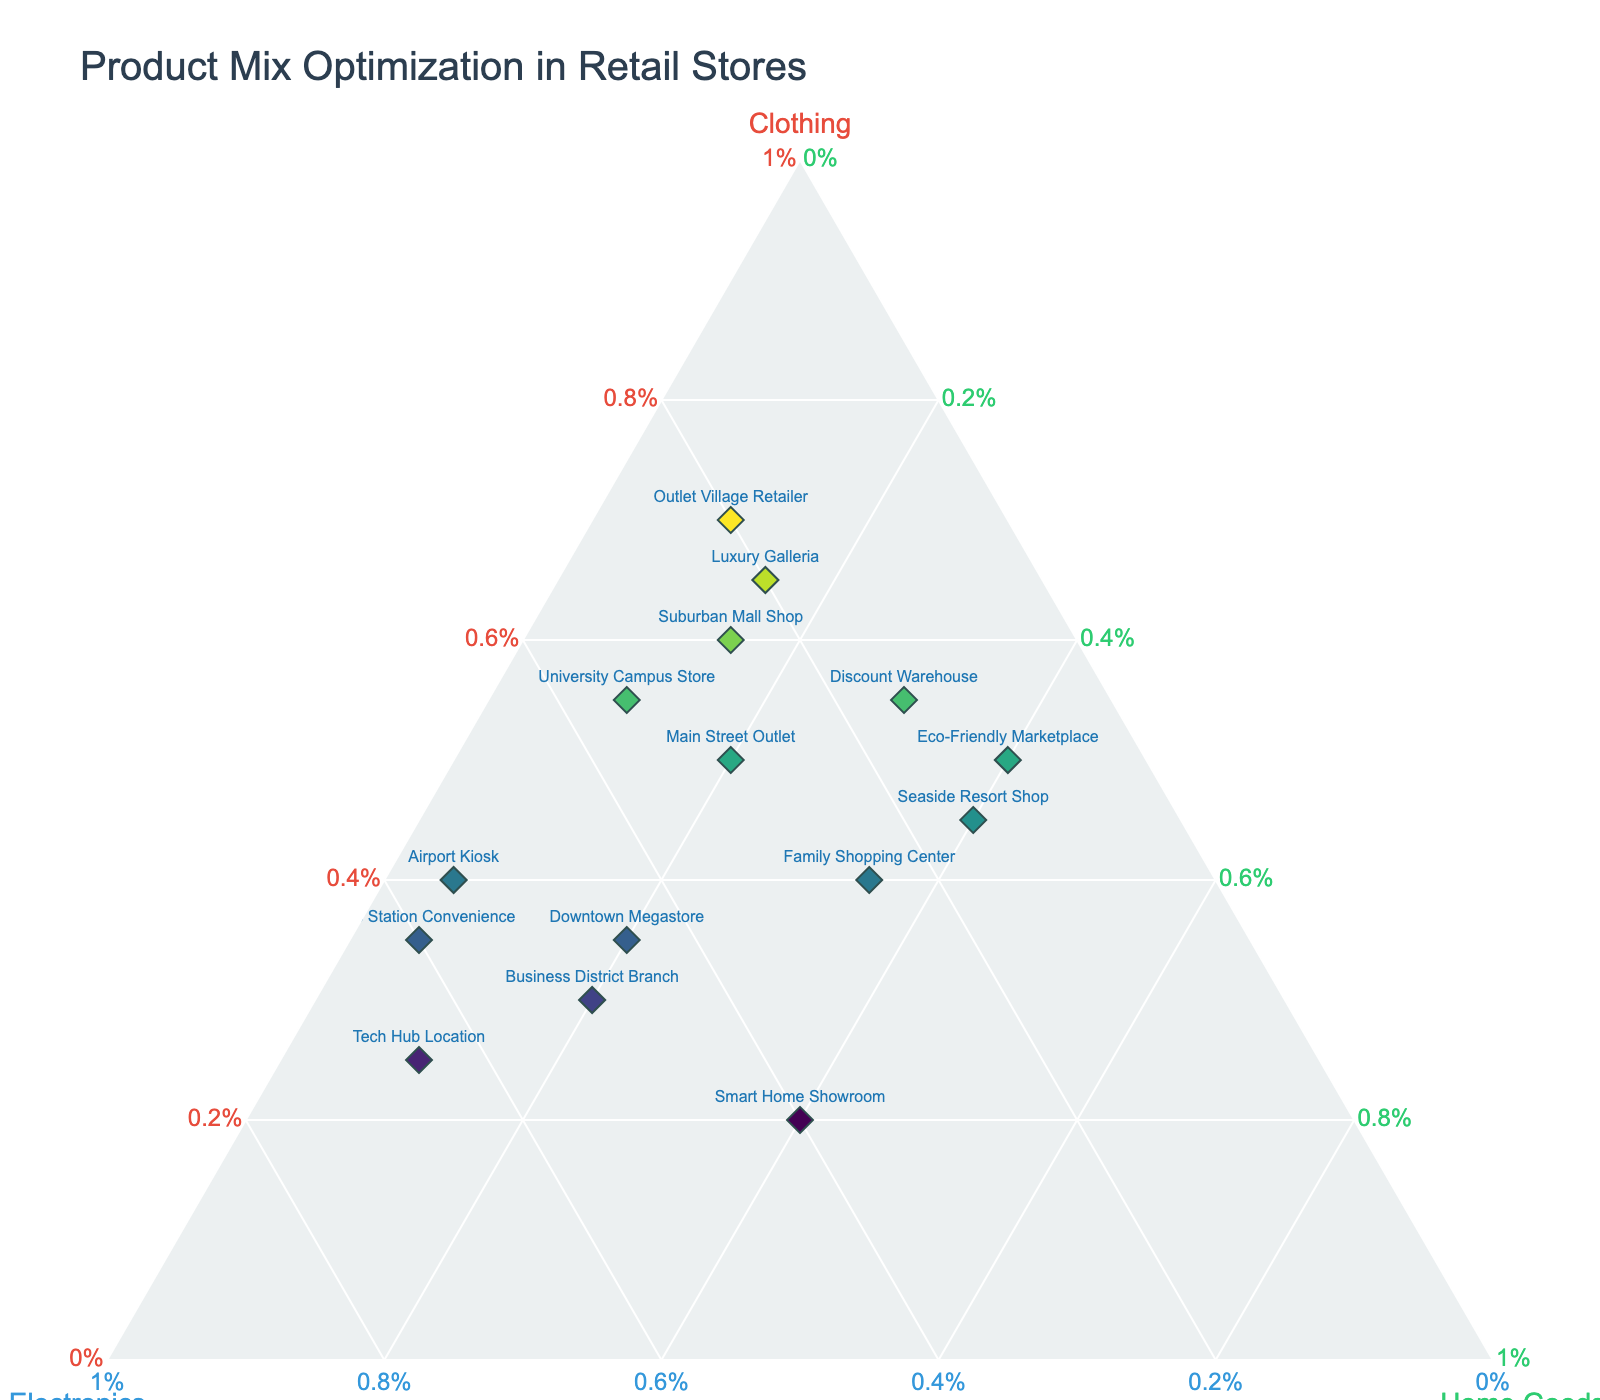what is the title of this plot? The title is the text at the top of the figure. In this case, "Product Mix Optimization in Retail Stores" is clearly shown.
Answer: Product Mix Optimization in Retail Stores Which store has the highest percentage of electronics? From the plot, the store with the highest percentage on the 'Electronics' axis is the "Tech Hub Location".
Answer: Tech Hub Location How many stores have clothing percentages between 40% and 60%? By examining the 'Clothing' axis, the stores with clothing percentages between 40% and 60% are Main Street Outlet, Airport Kiosk, University Campus Store, Seaside Resort Shop, Family Shopping Center, and Discount Warehouse. Counting these gives a total.
Answer: 6 Which store has the equal highest percentage of home goods and electronics? By identifying stores where the data points are equally divided between 'Home Goods' and 'Electronics' percentages, the "Smart Home Showroom" shows equal values.
Answer: Smart Home Showroom What is the sum of clothing percentages of "Luxury Galleria" and "Eco-Friendly Marketplace"? Identify the clothing percentages of both stores: "Luxury Galleria" has 65% and "Eco-Friendly Marketplace" has 50%. Adding these percentages gives 115%.
Answer: 115% Which store has the lowest percentage of home goods? By looking at the home goods axis, the lowest percentage is from the "Metro Station Convenience".
Answer: Metro Station Convenience Compare the clothing percentage between "Outlet Village Retailer" and "Downtown Megastore". Who has the higher value and what is the difference? "Outlet Village Retailer" has 70% clothing, and "Downtown Megastore" has 35%. The difference is 70% - 35% = 35%. Outlet Village Retailer has a higher value.
Answer: Outlet Village Retailer, 35% On average, what is the percentage of electronics across all stores? Sum all percentages of electronics from each store and divide by the number of stores: (30+45+25+55+35+20+50+15+65+25+15+20+60+10+40) / 15 = 36%.
Answer: 36% Which store has an equal or almost equal mix of all three categories? By looking for the store where the data point is near the center of the plot, "Smart Home Showroom" seems to have a balanced mix with 20% clothing, 40% electronics, and 40% home goods.
Answer: Smart Home Showroom 